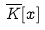<formula> <loc_0><loc_0><loc_500><loc_500>\overline { K } [ x ]</formula> 